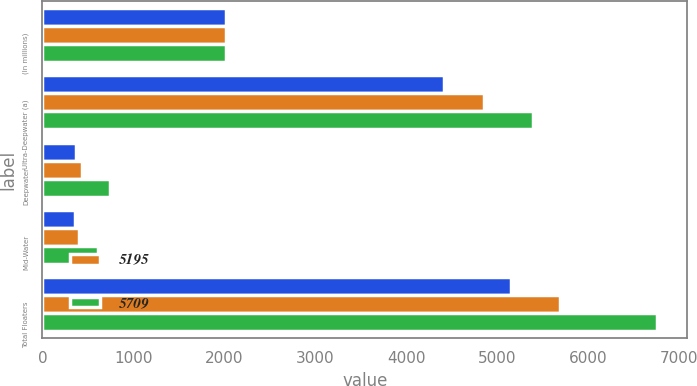<chart> <loc_0><loc_0><loc_500><loc_500><stacked_bar_chart><ecel><fcel>(In millions)<fcel>Ultra-Deepwater (a)<fcel>Deepwater<fcel>Mid-Water<fcel>Total Floaters<nl><fcel>nan<fcel>2016<fcel>4415<fcel>375<fcel>356<fcel>5146<nl><fcel>5195<fcel>2015<fcel>4851<fcel>439<fcel>401<fcel>5691<nl><fcel>5709<fcel>2015<fcel>5390<fcel>748<fcel>611<fcel>6749<nl></chart> 